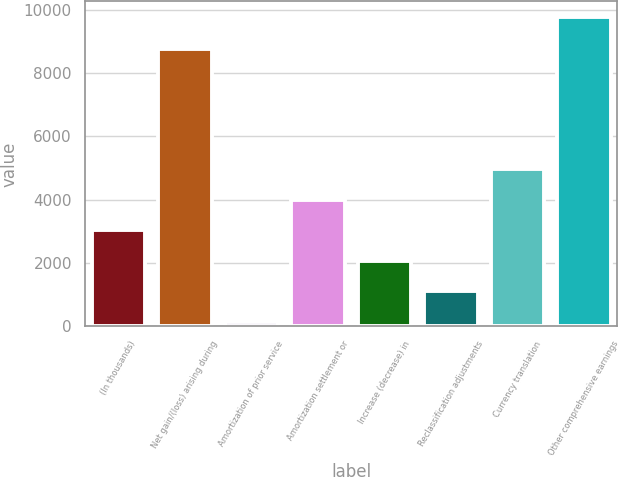<chart> <loc_0><loc_0><loc_500><loc_500><bar_chart><fcel>(In thousands)<fcel>Net gain/(loss) arising during<fcel>Amortization of prior service<fcel>Amortization settlement or<fcel>Increase (decrease) in<fcel>Reclassification adjustments<fcel>Currency translation<fcel>Other comprehensive earnings<nl><fcel>3032.7<fcel>8761<fcel>144<fcel>3995.6<fcel>2069.8<fcel>1106.9<fcel>4958.5<fcel>9773<nl></chart> 